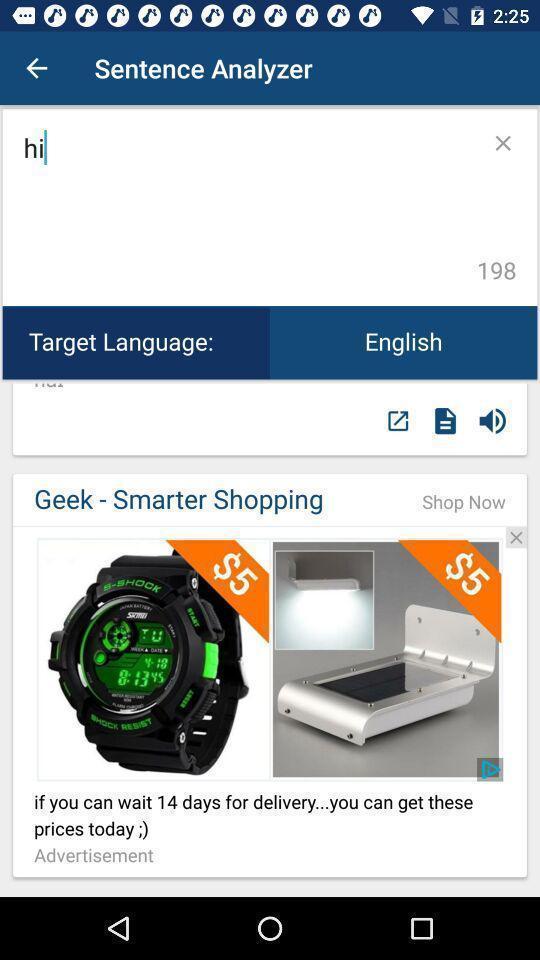What is the overall content of this screenshot? Screen page of learning application. 